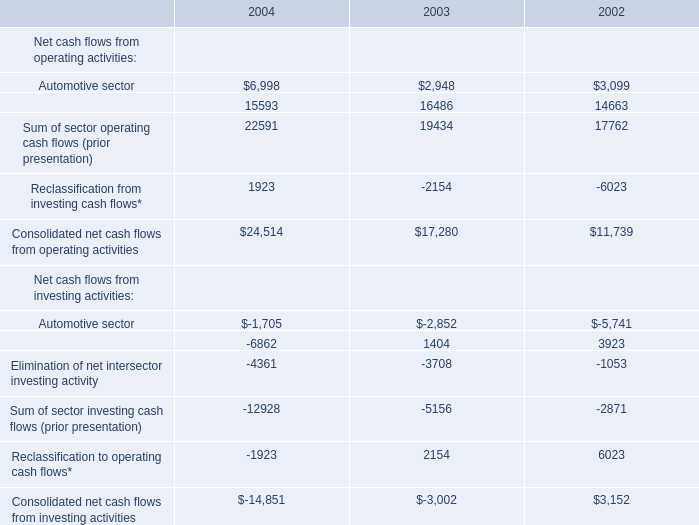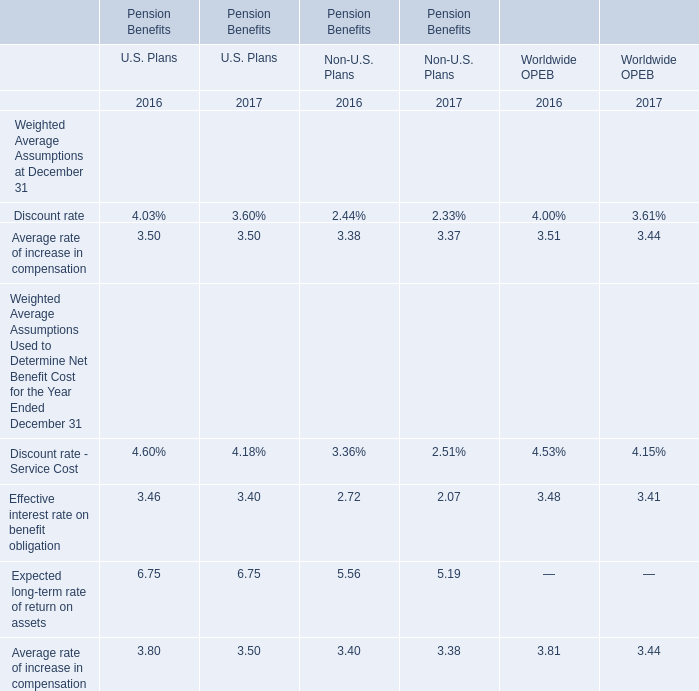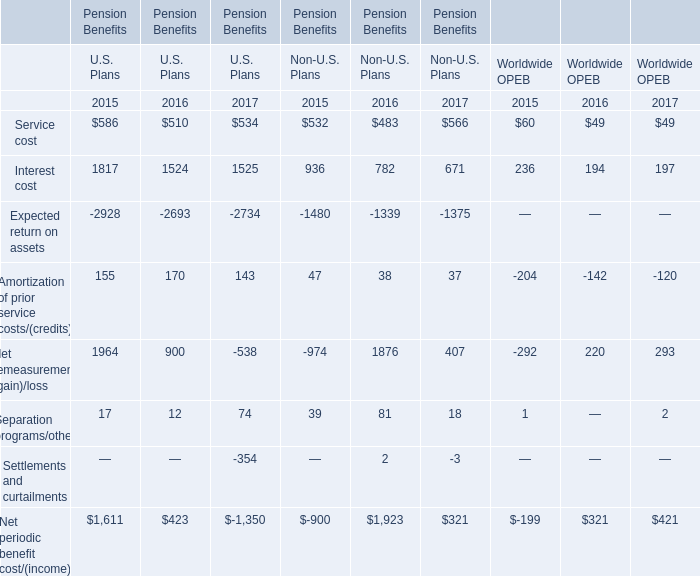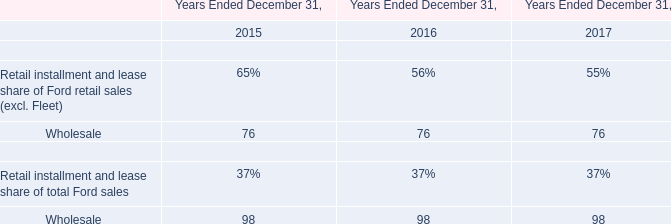In the year with the most Average rate of increase in compensation, what is the growth rate of Expected long-term rate of return on assets? 
Computations: (((6.75 + 5.19) - (6.75 + 5.56)) / (6.75 + 5.56))
Answer: -0.03006. 